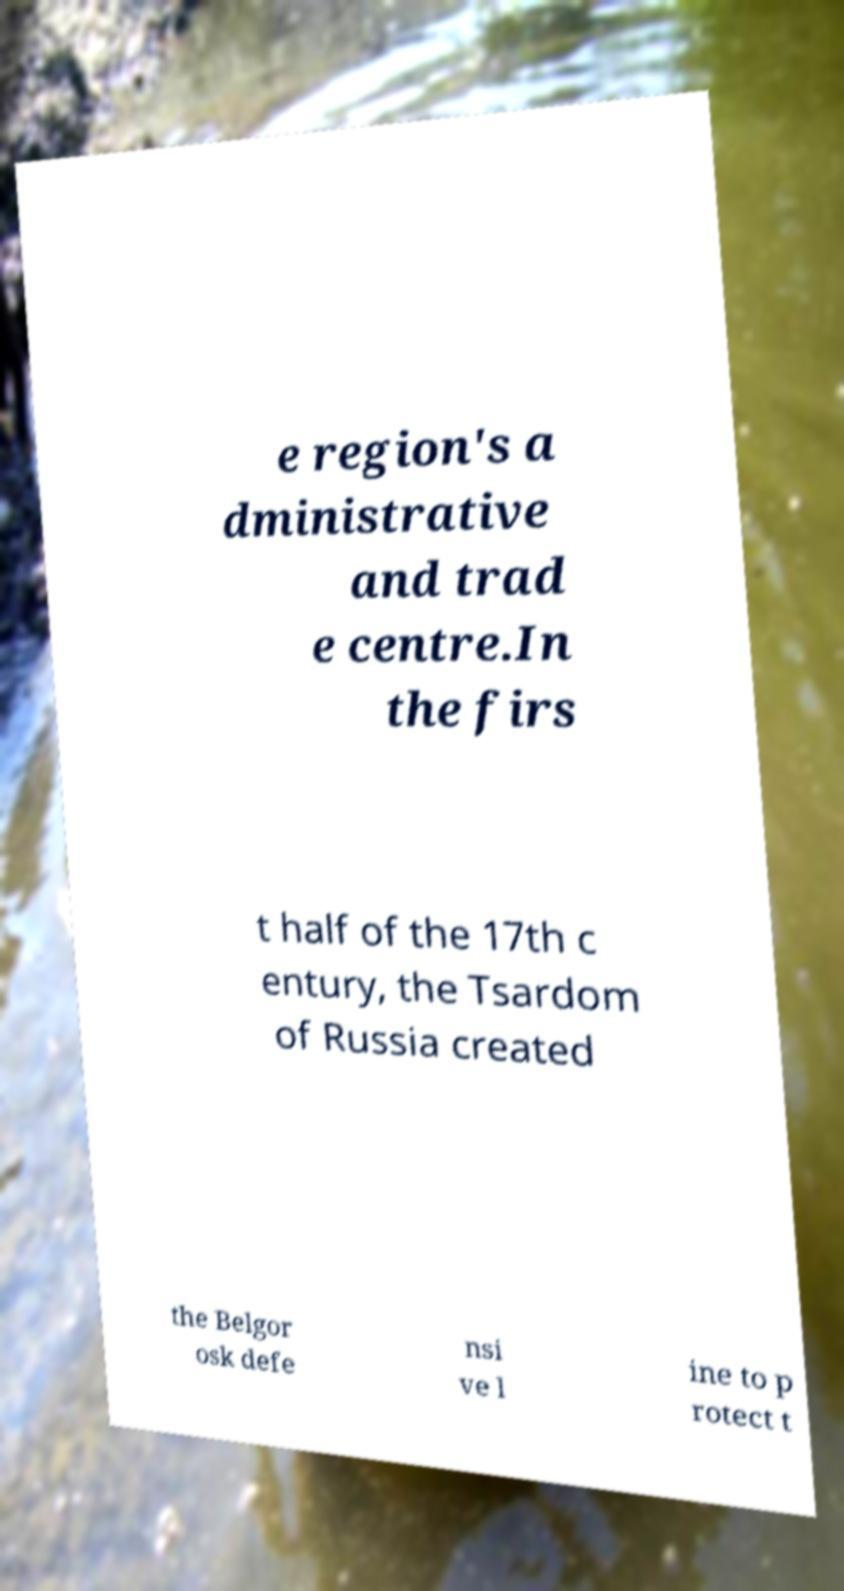I need the written content from this picture converted into text. Can you do that? e region's a dministrative and trad e centre.In the firs t half of the 17th c entury, the Tsardom of Russia created the Belgor osk defe nsi ve l ine to p rotect t 